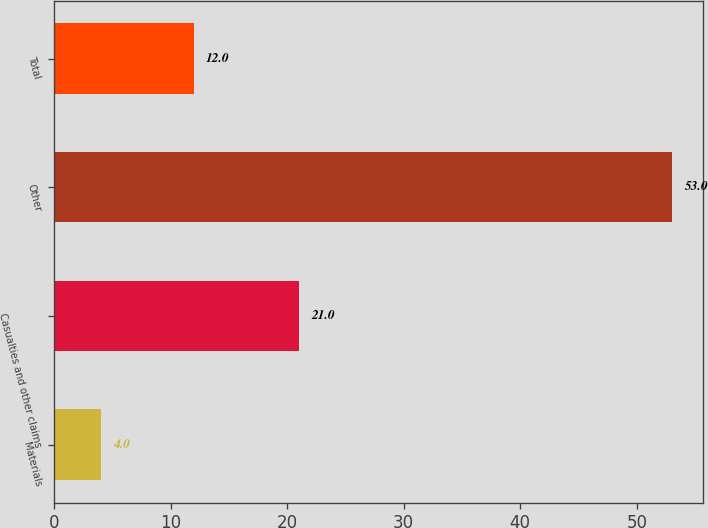Convert chart. <chart><loc_0><loc_0><loc_500><loc_500><bar_chart><fcel>Materials<fcel>Casualties and other claims<fcel>Other<fcel>Total<nl><fcel>4<fcel>21<fcel>53<fcel>12<nl></chart> 